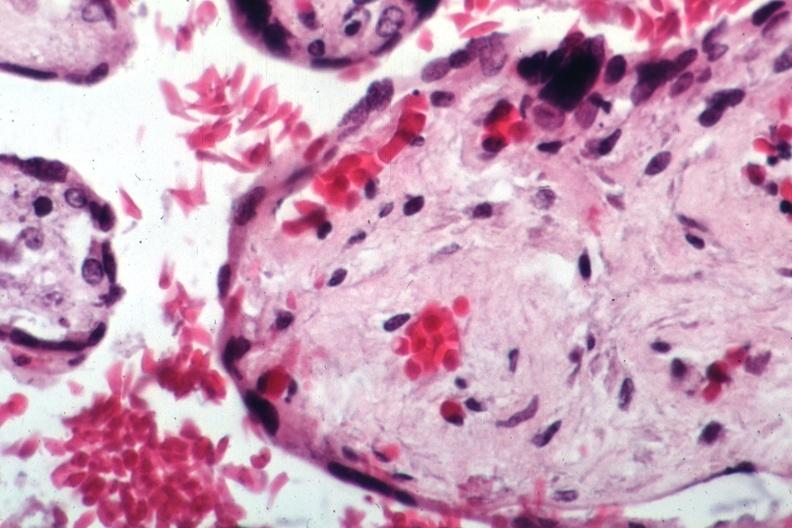what is present?
Answer the question using a single word or phrase. Sickle cell disease 